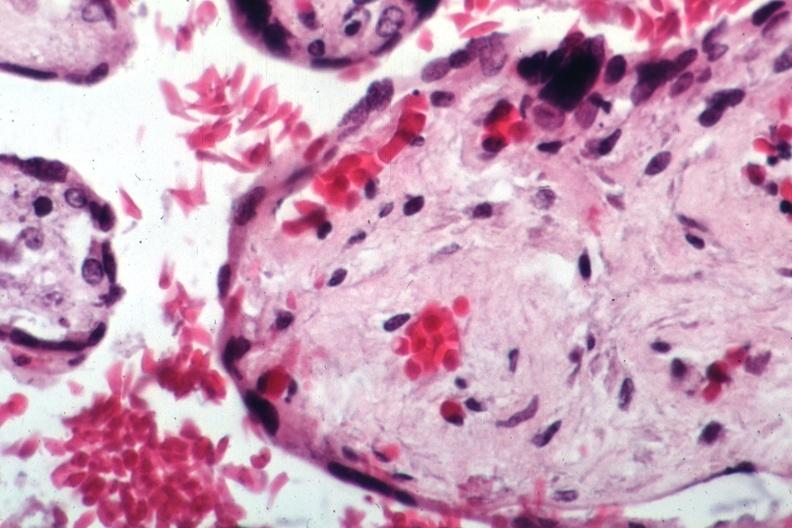what is present?
Answer the question using a single word or phrase. Sickle cell disease 